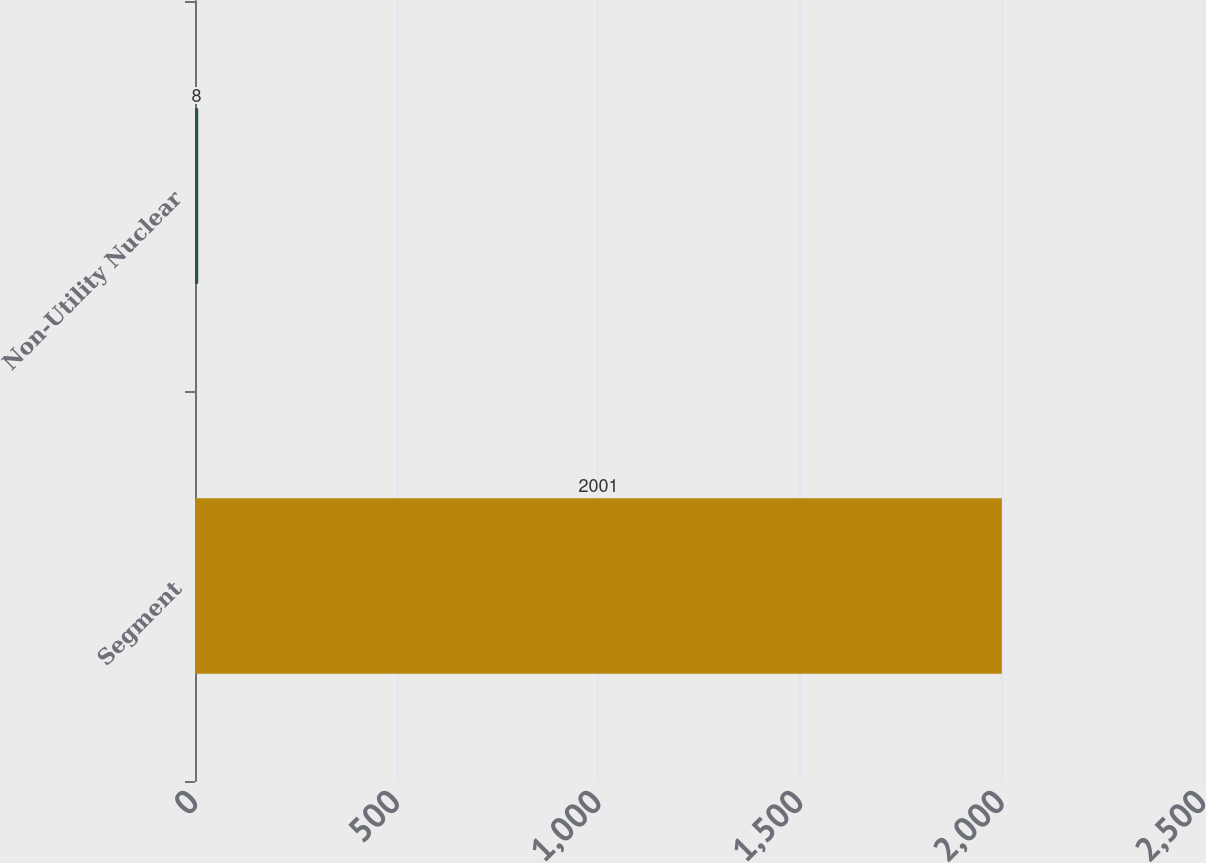Convert chart. <chart><loc_0><loc_0><loc_500><loc_500><bar_chart><fcel>Segment<fcel>Non-Utility Nuclear<nl><fcel>2001<fcel>8<nl></chart> 